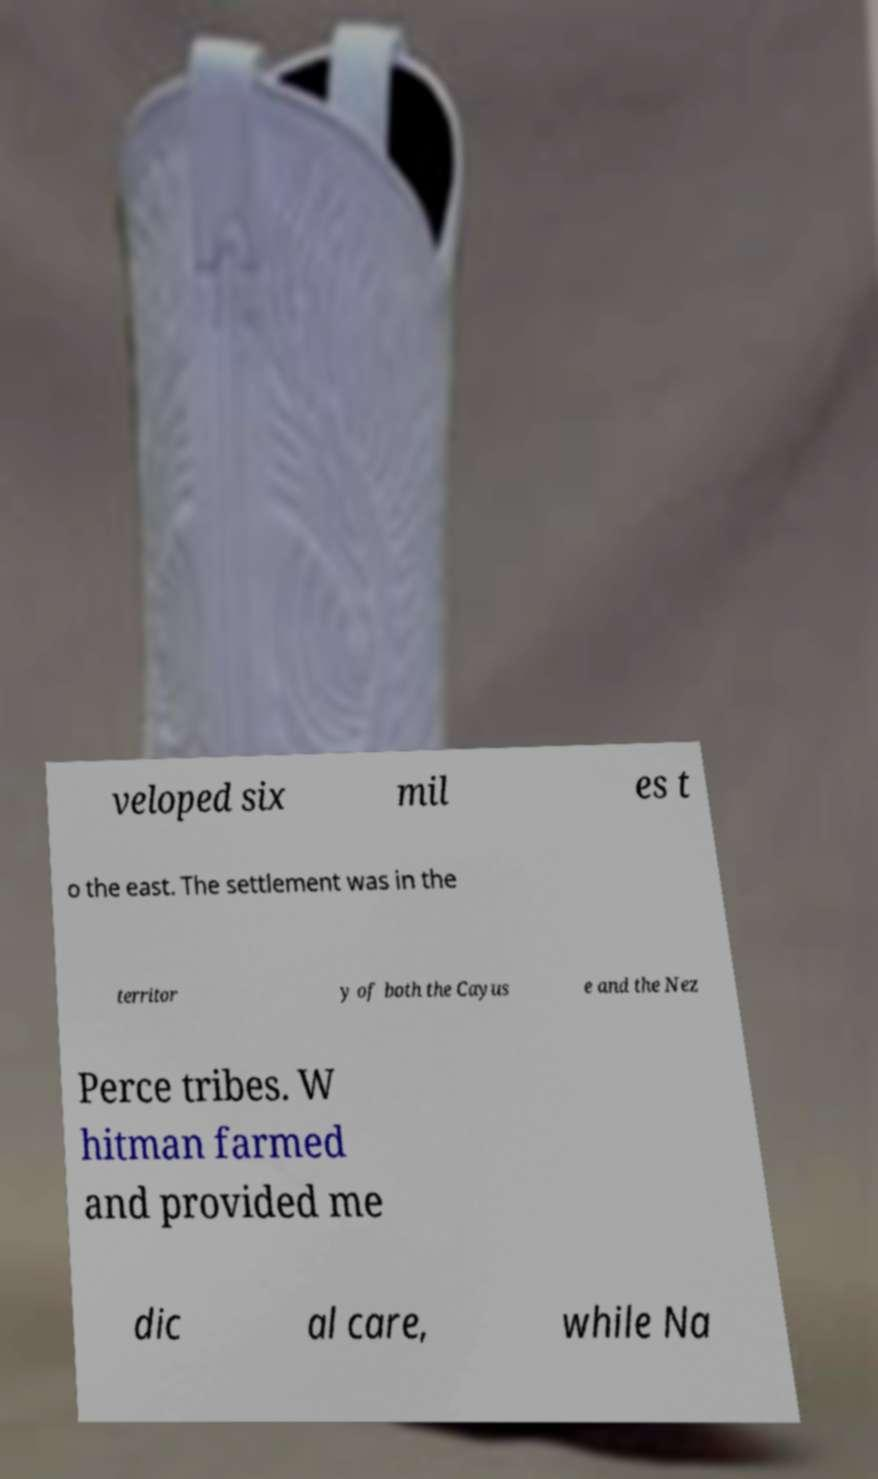Can you read and provide the text displayed in the image?This photo seems to have some interesting text. Can you extract and type it out for me? veloped six mil es t o the east. The settlement was in the territor y of both the Cayus e and the Nez Perce tribes. W hitman farmed and provided me dic al care, while Na 